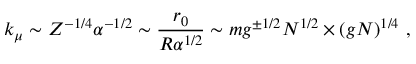Convert formula to latex. <formula><loc_0><loc_0><loc_500><loc_500>k _ { \mu } \sim Z ^ { - 1 / 4 } \alpha ^ { - 1 / 2 } \sim \frac { r _ { 0 } } { R \alpha ^ { 1 / 2 } } \sim m g ^ { \pm 1 / 2 } N ^ { 1 / 2 } \times ( g N ) ^ { 1 / 4 } \ ,</formula> 